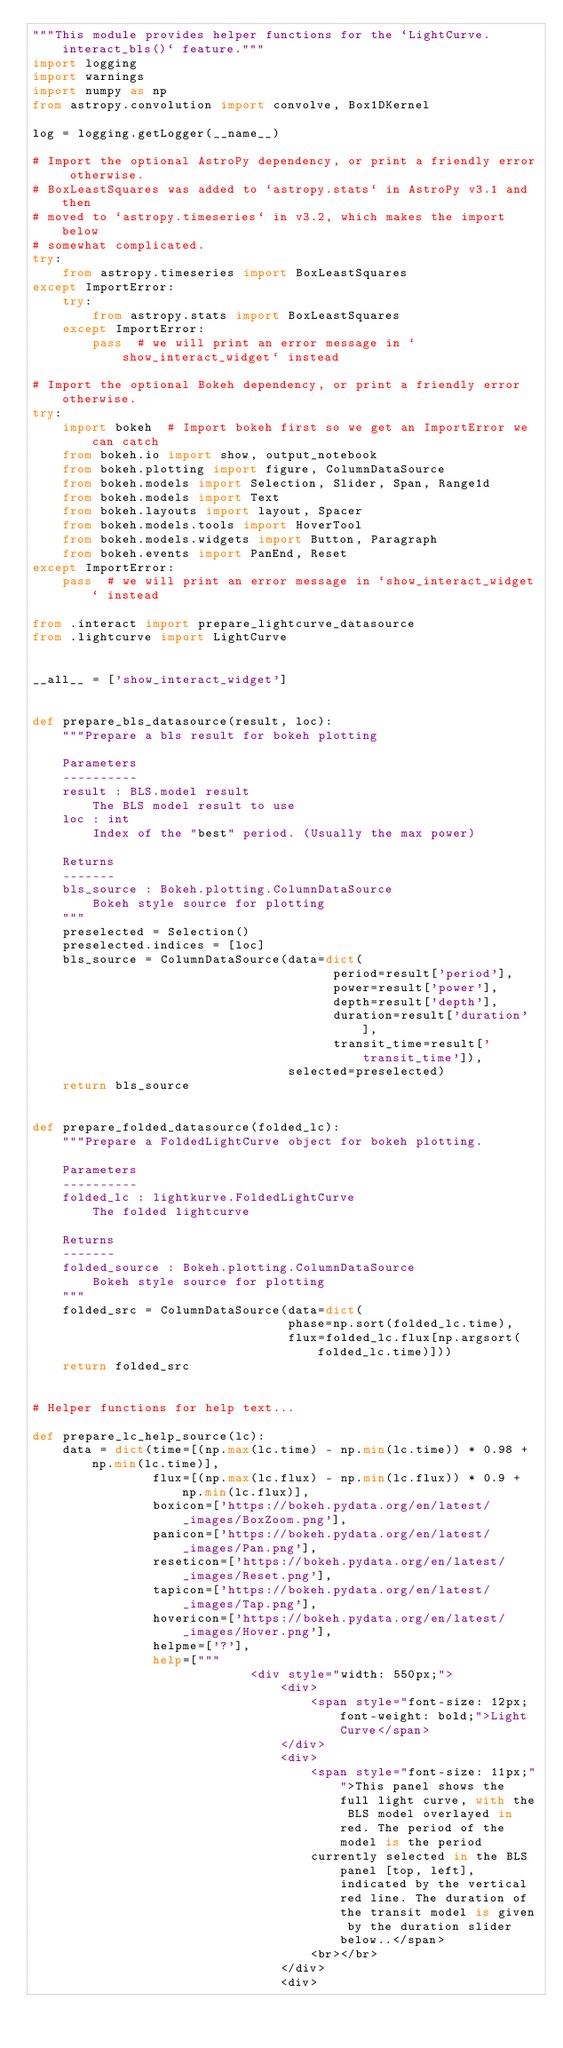Convert code to text. <code><loc_0><loc_0><loc_500><loc_500><_Python_>"""This module provides helper functions for the `LightCurve.interact_bls()` feature."""
import logging
import warnings
import numpy as np
from astropy.convolution import convolve, Box1DKernel

log = logging.getLogger(__name__)

# Import the optional AstroPy dependency, or print a friendly error otherwise.
# BoxLeastSquares was added to `astropy.stats` in AstroPy v3.1 and then
# moved to `astropy.timeseries` in v3.2, which makes the import below
# somewhat complicated.
try:
    from astropy.timeseries import BoxLeastSquares
except ImportError:
    try:
        from astropy.stats import BoxLeastSquares
    except ImportError:
        pass  # we will print an error message in `show_interact_widget` instead

# Import the optional Bokeh dependency, or print a friendly error otherwise.
try:
    import bokeh  # Import bokeh first so we get an ImportError we can catch
    from bokeh.io import show, output_notebook
    from bokeh.plotting import figure, ColumnDataSource
    from bokeh.models import Selection, Slider, Span, Range1d
    from bokeh.models import Text
    from bokeh.layouts import layout, Spacer
    from bokeh.models.tools import HoverTool
    from bokeh.models.widgets import Button, Paragraph
    from bokeh.events import PanEnd, Reset
except ImportError:
    pass  # we will print an error message in `show_interact_widget` instead

from .interact import prepare_lightcurve_datasource
from .lightcurve import LightCurve


__all__ = ['show_interact_widget']


def prepare_bls_datasource(result, loc):
    """Prepare a bls result for bokeh plotting

    Parameters
    ----------
    result : BLS.model result
        The BLS model result to use
    loc : int
        Index of the "best" period. (Usually the max power)

    Returns
    -------
    bls_source : Bokeh.plotting.ColumnDataSource
        Bokeh style source for plotting
    """
    preselected = Selection()
    preselected.indices = [loc]
    bls_source = ColumnDataSource(data=dict(
                                        period=result['period'],
                                        power=result['power'],
                                        depth=result['depth'],
                                        duration=result['duration'],
                                        transit_time=result['transit_time']),
                                  selected=preselected)
    return bls_source


def prepare_folded_datasource(folded_lc):
    """Prepare a FoldedLightCurve object for bokeh plotting.

    Parameters
    ----------
    folded_lc : lightkurve.FoldedLightCurve
        The folded lightcurve

    Returns
    -------
    folded_source : Bokeh.plotting.ColumnDataSource
        Bokeh style source for plotting
    """
    folded_src = ColumnDataSource(data=dict(
                                  phase=np.sort(folded_lc.time),
                                  flux=folded_lc.flux[np.argsort(folded_lc.time)]))
    return folded_src


# Helper functions for help text...

def prepare_lc_help_source(lc):
    data = dict(time=[(np.max(lc.time) - np.min(lc.time)) * 0.98 + np.min(lc.time)],
                flux=[(np.max(lc.flux) - np.min(lc.flux)) * 0.9 + np.min(lc.flux)],
                boxicon=['https://bokeh.pydata.org/en/latest/_images/BoxZoom.png'],
                panicon=['https://bokeh.pydata.org/en/latest/_images/Pan.png'],
                reseticon=['https://bokeh.pydata.org/en/latest/_images/Reset.png'],
                tapicon=['https://bokeh.pydata.org/en/latest/_images/Tap.png'],
                hovericon=['https://bokeh.pydata.org/en/latest/_images/Hover.png'],
                helpme=['?'],
                help=["""
                             <div style="width: 550px;">
                                 <div>
                                     <span style="font-size: 12px; font-weight: bold;">Light Curve</span>
                                 </div>
                                 <div>
                                     <span style="font-size: 11px;"">This panel shows the full light curve, with the BLS model overlayed in red. The period of the model is the period
                                     currently selected in the BLS panel [top, left], indicated by the vertical red line. The duration of the transit model is given by the duration slider below..</span>
                                     <br></br>
                                 </div>
                                 <div></code> 